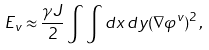<formula> <loc_0><loc_0><loc_500><loc_500>E _ { v } \approx \frac { \gamma J } { 2 } \int \int d x \, d y ( \nabla \varphi ^ { v } ) ^ { 2 } \, ,</formula> 